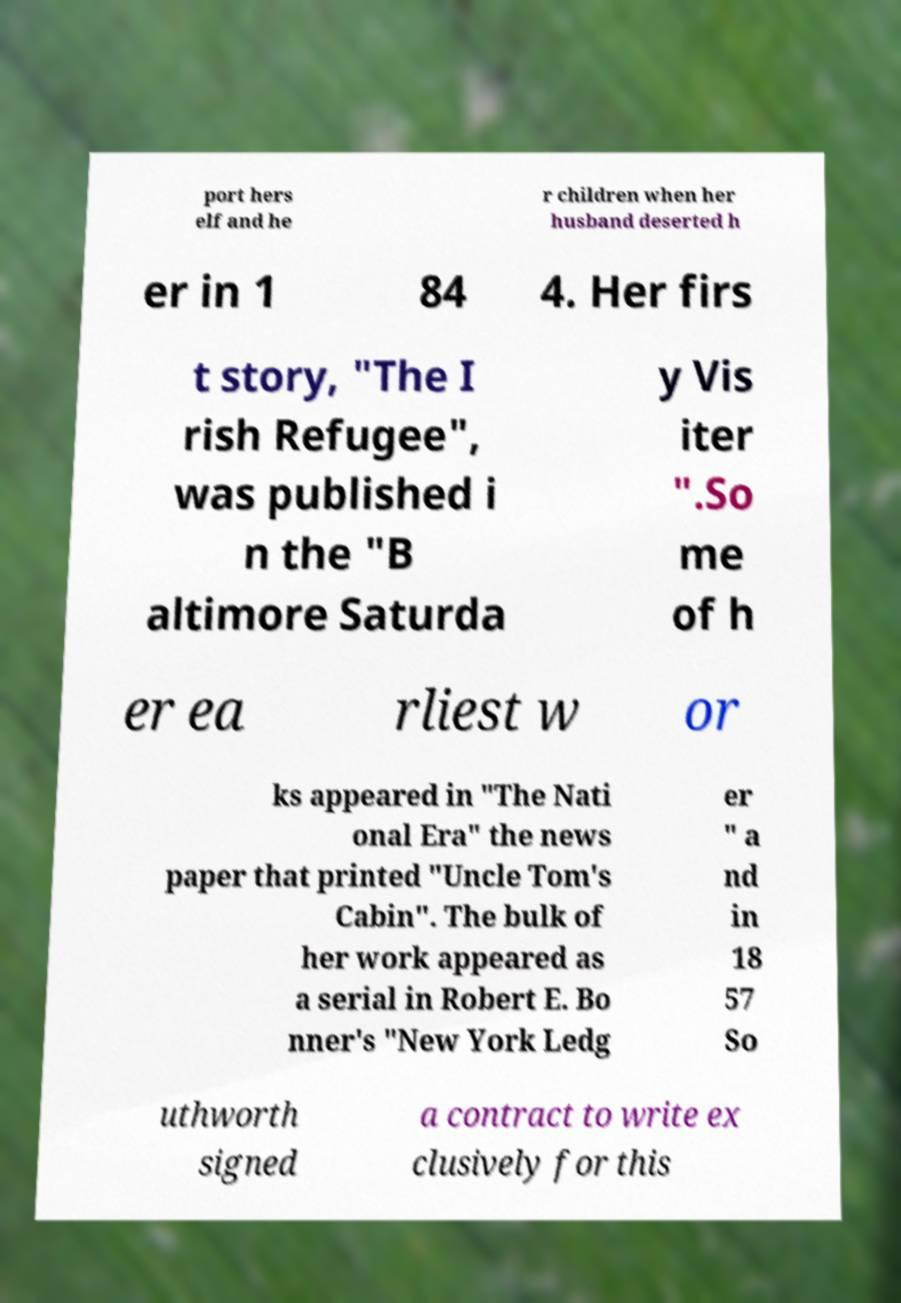Please identify and transcribe the text found in this image. port hers elf and he r children when her husband deserted h er in 1 84 4. Her firs t story, "The I rish Refugee", was published i n the "B altimore Saturda y Vis iter ".So me of h er ea rliest w or ks appeared in "The Nati onal Era" the news paper that printed "Uncle Tom's Cabin". The bulk of her work appeared as a serial in Robert E. Bo nner's "New York Ledg er " a nd in 18 57 So uthworth signed a contract to write ex clusively for this 